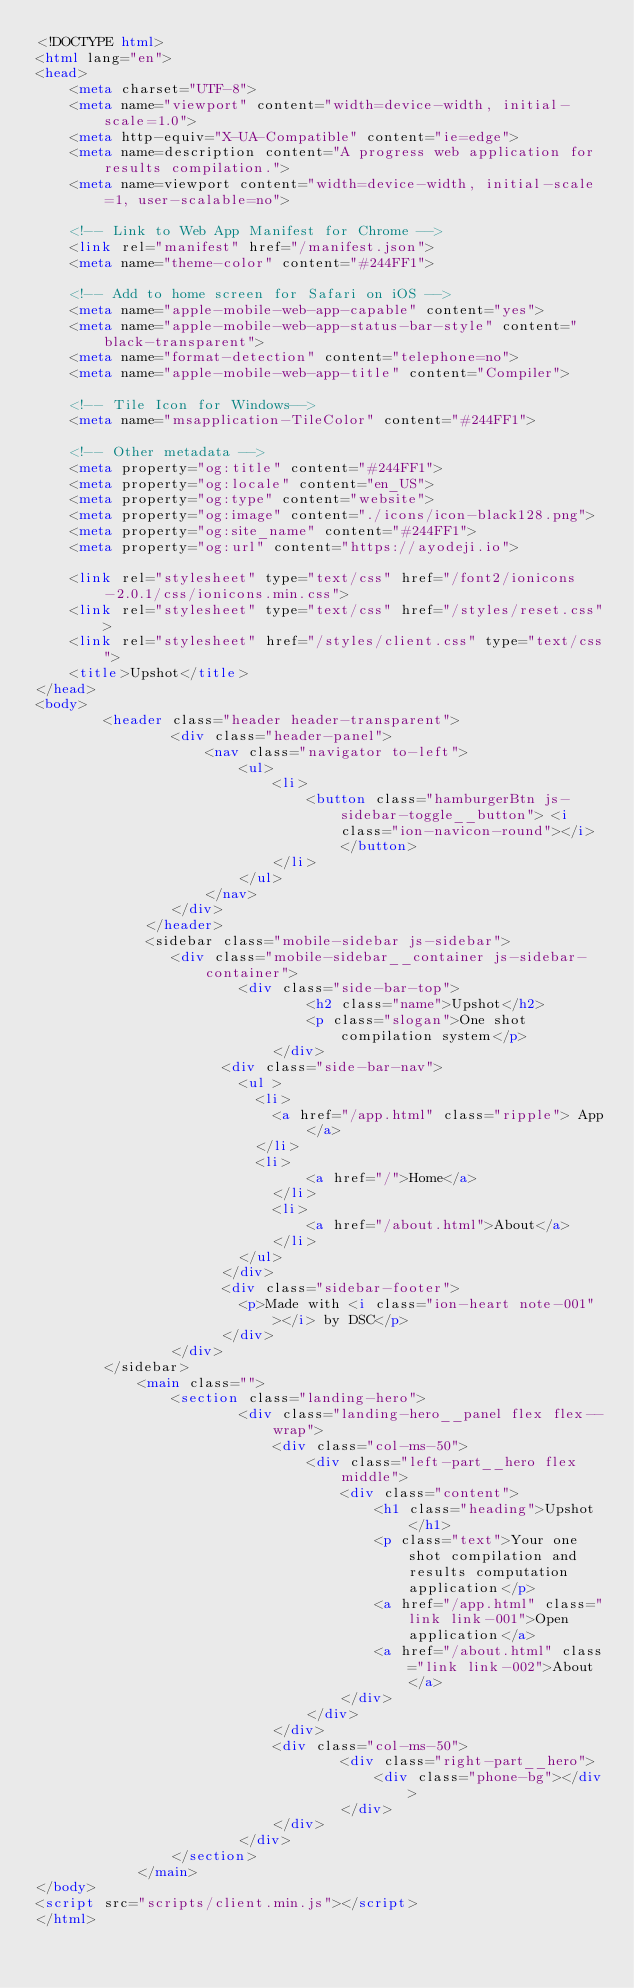Convert code to text. <code><loc_0><loc_0><loc_500><loc_500><_HTML_><!DOCTYPE html>
<html lang="en">
<head>
    <meta charset="UTF-8">
    <meta name="viewport" content="width=device-width, initial-scale=1.0">
    <meta http-equiv="X-UA-Compatible" content="ie=edge">
    <meta name=description content="A progress web application for results compilation.">
    <meta name=viewport content="width=device-width, initial-scale=1, user-scalable=no">

    <!-- Link to Web App Manifest for Chrome -->
	<link rel="manifest" href="/manifest.json">
    <meta name="theme-color" content="#244FF1">

	<!-- Add to home screen for Safari on iOS -->
	<meta name="apple-mobile-web-app-capable" content="yes">
	<meta name="apple-mobile-web-app-status-bar-style" content="black-transparent">
	<meta name="format-detection" content="telephone=no">
	<meta name="apple-mobile-web-app-title" content="Compiler">

	<!-- Tile Icon for Windows-->
	<meta name="msapplication-TileColor" content="#244FF1">

	<!-- Other metadata -->
	<meta property="og:title" content="#244FF1">
	<meta property="og:locale" content="en_US">
	<meta property="og:type" content="website">
	<meta property="og:image" content="./icons/icon-black128.png">
	<meta property="og:site_name" content="#244FF1">
	<meta property="og:url" content="https://ayodeji.io">

    <link rel="stylesheet" type="text/css" href="/font2/ionicons-2.0.1/css/ionicons.min.css">
    <link rel="stylesheet" type="text/css" href="/styles/reset.css">
    <link rel="stylesheet" href="/styles/client.css" type="text/css">
    <title>Upshot</title>
</head>
<body>
		<header class="header header-transparent">
				<div class="header-panel">
					<nav class="navigator to-left">
						<ul>
							<li>
								<button class="hamburgerBtn js-sidebar-toggle__button"> <i class="ion-navicon-round"></i> </button>
							</li>
						</ul>
					</nav>
				</div>
			 </header>
			 <sidebar class="mobile-sidebar js-sidebar">
				<div class="mobile-sidebar__container js-sidebar-container">
						<div class="side-bar-top">
								<h2 class="name">Upshot</h2>
								<p class="slogan">One shot compilation system</p>
							</div>
					  <div class="side-bar-nav">
						<ul >
						  <li>
							<a href="/app.html" class="ripple"> App</a>
						  </li>
						  <li>
								<a href="/">Home</a>
							</li>
							<li>
								<a href="/about.html">About</a>
							</li>
						</ul>
					  </div>
					  <div class="sidebar-footer">
						<p>Made with <i class="ion-heart note-001"></i> by DSC</p>
					  </div>
				</div>
		</sidebar>
			<main class="">
				<section class="landing-hero">
						<div class="landing-hero__panel flex flex--wrap">
							<div class="col-ms-50">
								<div class="left-part__hero flex middle">
									<div class="content">
										<h1 class="heading">Upshot</h1>
										<p class="text">Your one shot compilation and results computation application</p>
										<a href="/app.html" class="link link-001">Open application</a>
										<a href="/about.html" class="link link-002">About</a>
									</div>
								</div>
							</div>
							<div class="col-ms-50">
									<div class="right-part__hero">
										<div class="phone-bg"></div>
									</div>
							</div>
						</div>
				</section>
			</main>
</body>
<script src="scripts/client.min.js"></script>
</html></code> 